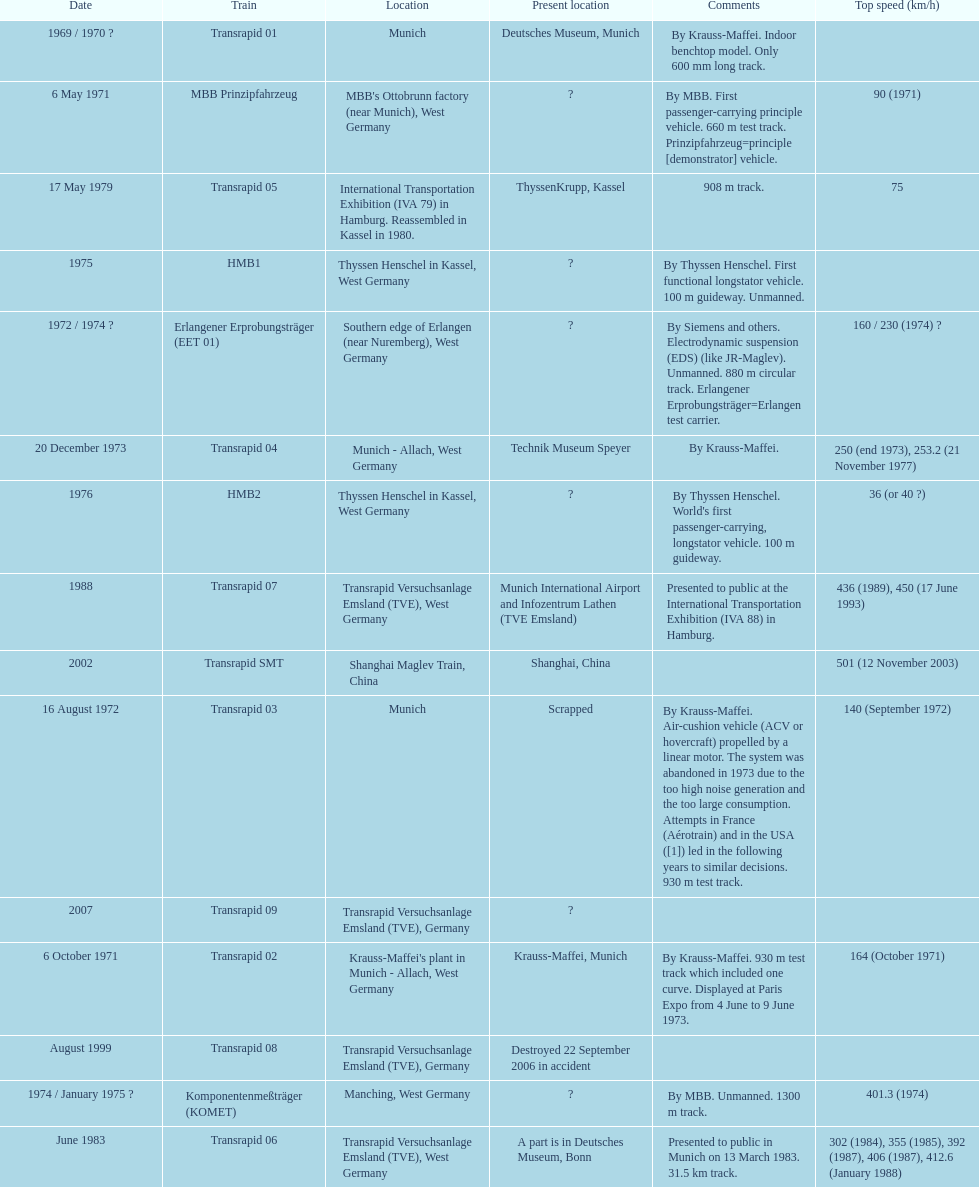Which train has the least top speed? HMB2. 